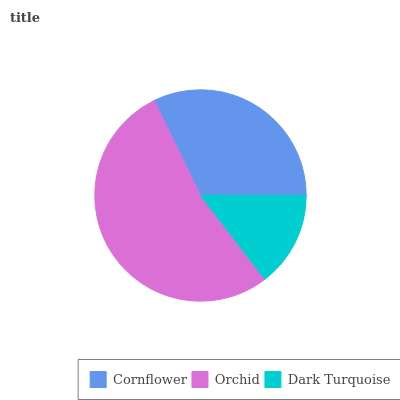Is Dark Turquoise the minimum?
Answer yes or no. Yes. Is Orchid the maximum?
Answer yes or no. Yes. Is Orchid the minimum?
Answer yes or no. No. Is Dark Turquoise the maximum?
Answer yes or no. No. Is Orchid greater than Dark Turquoise?
Answer yes or no. Yes. Is Dark Turquoise less than Orchid?
Answer yes or no. Yes. Is Dark Turquoise greater than Orchid?
Answer yes or no. No. Is Orchid less than Dark Turquoise?
Answer yes or no. No. Is Cornflower the high median?
Answer yes or no. Yes. Is Cornflower the low median?
Answer yes or no. Yes. Is Orchid the high median?
Answer yes or no. No. Is Orchid the low median?
Answer yes or no. No. 